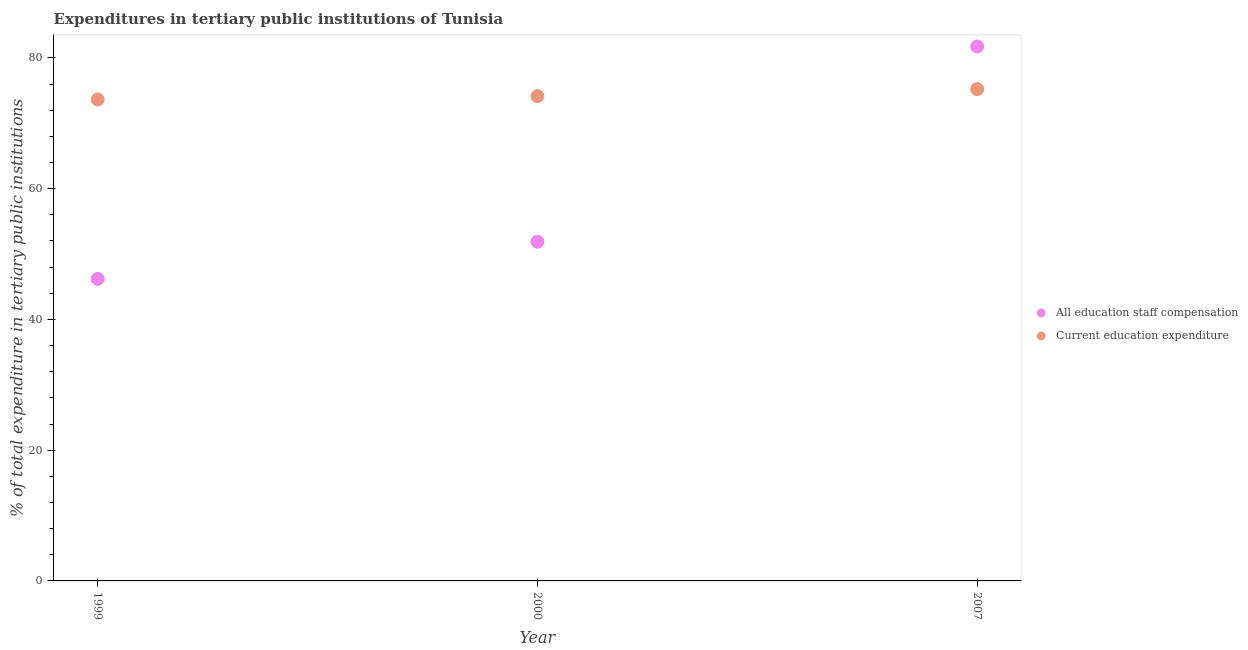How many different coloured dotlines are there?
Your answer should be compact. 2. Is the number of dotlines equal to the number of legend labels?
Your response must be concise. Yes. What is the expenditure in staff compensation in 2007?
Give a very brief answer. 81.74. Across all years, what is the maximum expenditure in education?
Keep it short and to the point. 75.23. Across all years, what is the minimum expenditure in education?
Give a very brief answer. 73.64. In which year was the expenditure in education minimum?
Make the answer very short. 1999. What is the total expenditure in education in the graph?
Keep it short and to the point. 223.02. What is the difference between the expenditure in education in 2000 and that in 2007?
Offer a very short reply. -1.08. What is the difference between the expenditure in education in 2007 and the expenditure in staff compensation in 2000?
Offer a very short reply. 23.35. What is the average expenditure in education per year?
Your response must be concise. 74.34. In the year 2007, what is the difference between the expenditure in staff compensation and expenditure in education?
Offer a terse response. 6.51. In how many years, is the expenditure in staff compensation greater than 32 %?
Keep it short and to the point. 3. What is the ratio of the expenditure in education in 1999 to that in 2007?
Your answer should be very brief. 0.98. Is the difference between the expenditure in education in 2000 and 2007 greater than the difference between the expenditure in staff compensation in 2000 and 2007?
Offer a terse response. Yes. What is the difference between the highest and the second highest expenditure in staff compensation?
Provide a short and direct response. 29.86. What is the difference between the highest and the lowest expenditure in education?
Keep it short and to the point. 1.59. Does the expenditure in staff compensation monotonically increase over the years?
Your response must be concise. Yes. Is the expenditure in education strictly greater than the expenditure in staff compensation over the years?
Provide a short and direct response. No. Is the expenditure in staff compensation strictly less than the expenditure in education over the years?
Your answer should be compact. No. How many dotlines are there?
Provide a succinct answer. 2. How many years are there in the graph?
Make the answer very short. 3. What is the difference between two consecutive major ticks on the Y-axis?
Your answer should be very brief. 20. Does the graph contain any zero values?
Give a very brief answer. No. Does the graph contain grids?
Your answer should be very brief. No. How many legend labels are there?
Ensure brevity in your answer.  2. How are the legend labels stacked?
Make the answer very short. Vertical. What is the title of the graph?
Keep it short and to the point. Expenditures in tertiary public institutions of Tunisia. Does "Investment in Telecom" appear as one of the legend labels in the graph?
Provide a succinct answer. No. What is the label or title of the X-axis?
Your answer should be compact. Year. What is the label or title of the Y-axis?
Make the answer very short. % of total expenditure in tertiary public institutions. What is the % of total expenditure in tertiary public institutions in All education staff compensation in 1999?
Your answer should be compact. 46.2. What is the % of total expenditure in tertiary public institutions in Current education expenditure in 1999?
Your answer should be very brief. 73.64. What is the % of total expenditure in tertiary public institutions of All education staff compensation in 2000?
Your response must be concise. 51.88. What is the % of total expenditure in tertiary public institutions in Current education expenditure in 2000?
Offer a very short reply. 74.15. What is the % of total expenditure in tertiary public institutions in All education staff compensation in 2007?
Provide a succinct answer. 81.74. What is the % of total expenditure in tertiary public institutions of Current education expenditure in 2007?
Your answer should be very brief. 75.23. Across all years, what is the maximum % of total expenditure in tertiary public institutions in All education staff compensation?
Your answer should be very brief. 81.74. Across all years, what is the maximum % of total expenditure in tertiary public institutions in Current education expenditure?
Offer a terse response. 75.23. Across all years, what is the minimum % of total expenditure in tertiary public institutions in All education staff compensation?
Your response must be concise. 46.2. Across all years, what is the minimum % of total expenditure in tertiary public institutions of Current education expenditure?
Your response must be concise. 73.64. What is the total % of total expenditure in tertiary public institutions of All education staff compensation in the graph?
Give a very brief answer. 179.82. What is the total % of total expenditure in tertiary public institutions of Current education expenditure in the graph?
Offer a terse response. 223.02. What is the difference between the % of total expenditure in tertiary public institutions of All education staff compensation in 1999 and that in 2000?
Offer a very short reply. -5.69. What is the difference between the % of total expenditure in tertiary public institutions of Current education expenditure in 1999 and that in 2000?
Keep it short and to the point. -0.5. What is the difference between the % of total expenditure in tertiary public institutions of All education staff compensation in 1999 and that in 2007?
Your response must be concise. -35.55. What is the difference between the % of total expenditure in tertiary public institutions in Current education expenditure in 1999 and that in 2007?
Your answer should be compact. -1.59. What is the difference between the % of total expenditure in tertiary public institutions of All education staff compensation in 2000 and that in 2007?
Your answer should be very brief. -29.86. What is the difference between the % of total expenditure in tertiary public institutions of Current education expenditure in 2000 and that in 2007?
Offer a very short reply. -1.08. What is the difference between the % of total expenditure in tertiary public institutions of All education staff compensation in 1999 and the % of total expenditure in tertiary public institutions of Current education expenditure in 2000?
Your response must be concise. -27.95. What is the difference between the % of total expenditure in tertiary public institutions in All education staff compensation in 1999 and the % of total expenditure in tertiary public institutions in Current education expenditure in 2007?
Offer a terse response. -29.03. What is the difference between the % of total expenditure in tertiary public institutions of All education staff compensation in 2000 and the % of total expenditure in tertiary public institutions of Current education expenditure in 2007?
Ensure brevity in your answer.  -23.35. What is the average % of total expenditure in tertiary public institutions of All education staff compensation per year?
Ensure brevity in your answer.  59.94. What is the average % of total expenditure in tertiary public institutions of Current education expenditure per year?
Provide a short and direct response. 74.34. In the year 1999, what is the difference between the % of total expenditure in tertiary public institutions of All education staff compensation and % of total expenditure in tertiary public institutions of Current education expenditure?
Your response must be concise. -27.45. In the year 2000, what is the difference between the % of total expenditure in tertiary public institutions of All education staff compensation and % of total expenditure in tertiary public institutions of Current education expenditure?
Offer a very short reply. -22.26. In the year 2007, what is the difference between the % of total expenditure in tertiary public institutions in All education staff compensation and % of total expenditure in tertiary public institutions in Current education expenditure?
Offer a terse response. 6.51. What is the ratio of the % of total expenditure in tertiary public institutions in All education staff compensation in 1999 to that in 2000?
Give a very brief answer. 0.89. What is the ratio of the % of total expenditure in tertiary public institutions of Current education expenditure in 1999 to that in 2000?
Your response must be concise. 0.99. What is the ratio of the % of total expenditure in tertiary public institutions of All education staff compensation in 1999 to that in 2007?
Your response must be concise. 0.57. What is the ratio of the % of total expenditure in tertiary public institutions in Current education expenditure in 1999 to that in 2007?
Your response must be concise. 0.98. What is the ratio of the % of total expenditure in tertiary public institutions of All education staff compensation in 2000 to that in 2007?
Give a very brief answer. 0.63. What is the ratio of the % of total expenditure in tertiary public institutions of Current education expenditure in 2000 to that in 2007?
Provide a short and direct response. 0.99. What is the difference between the highest and the second highest % of total expenditure in tertiary public institutions in All education staff compensation?
Make the answer very short. 29.86. What is the difference between the highest and the second highest % of total expenditure in tertiary public institutions in Current education expenditure?
Offer a terse response. 1.08. What is the difference between the highest and the lowest % of total expenditure in tertiary public institutions of All education staff compensation?
Provide a succinct answer. 35.55. What is the difference between the highest and the lowest % of total expenditure in tertiary public institutions of Current education expenditure?
Ensure brevity in your answer.  1.59. 